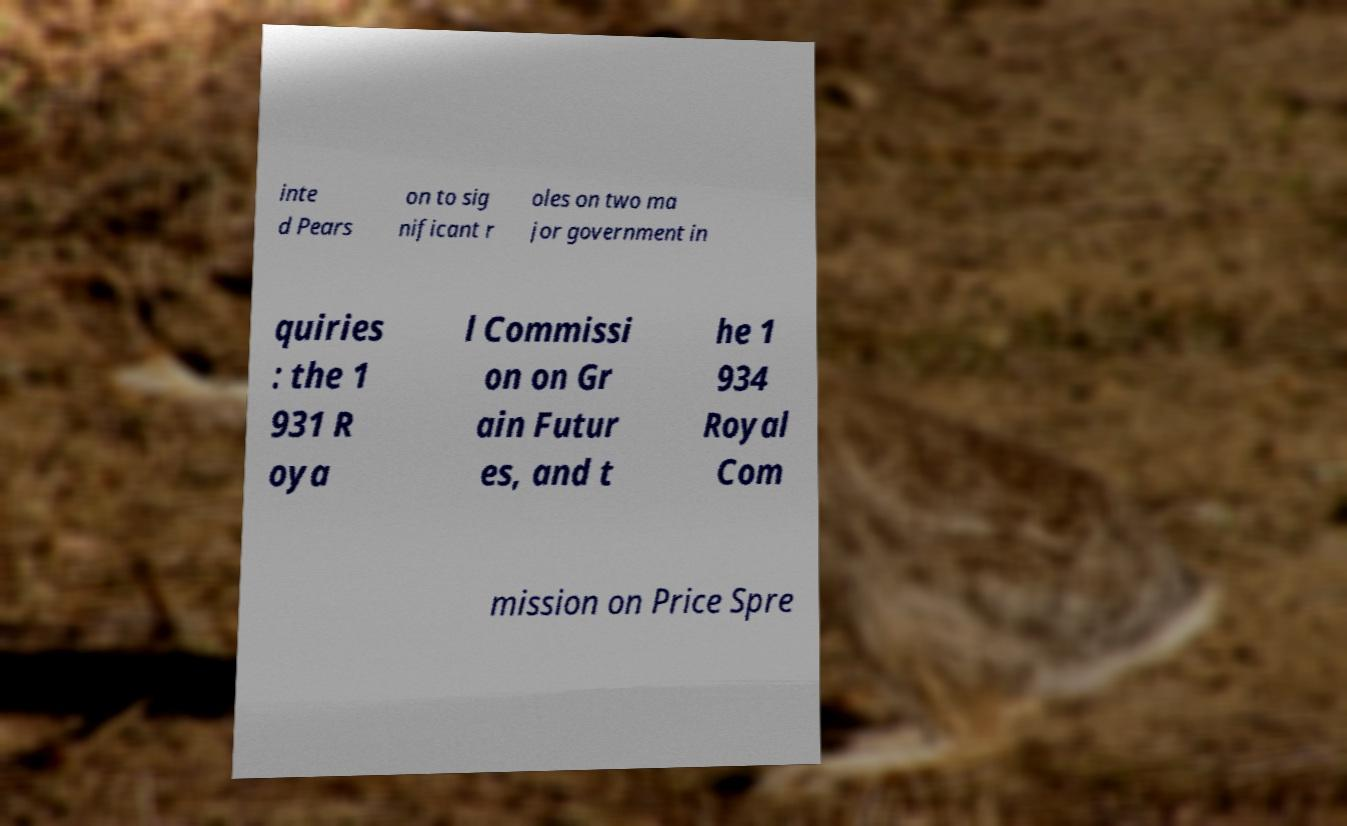There's text embedded in this image that I need extracted. Can you transcribe it verbatim? inte d Pears on to sig nificant r oles on two ma jor government in quiries : the 1 931 R oya l Commissi on on Gr ain Futur es, and t he 1 934 Royal Com mission on Price Spre 